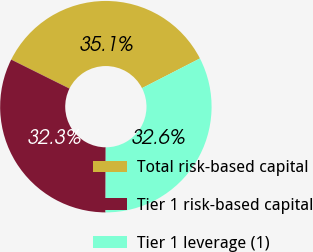<chart> <loc_0><loc_0><loc_500><loc_500><pie_chart><fcel>Total risk-based capital<fcel>Tier 1 risk-based capital<fcel>Tier 1 leverage (1)<nl><fcel>35.11%<fcel>32.3%<fcel>32.58%<nl></chart> 